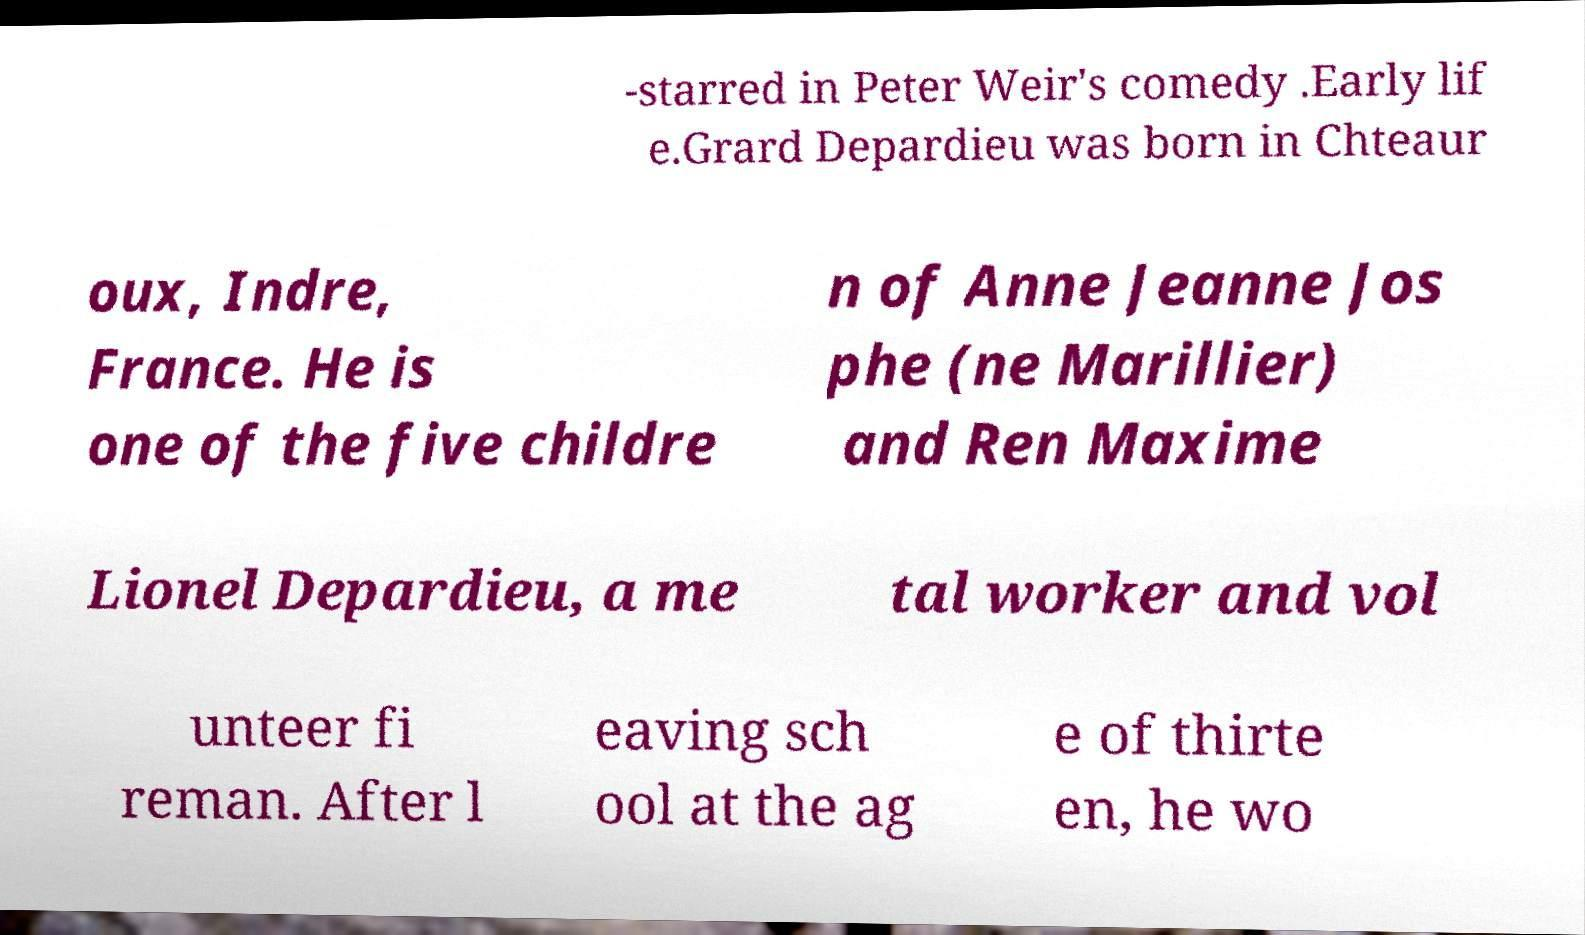Please identify and transcribe the text found in this image. -starred in Peter Weir's comedy .Early lif e.Grard Depardieu was born in Chteaur oux, Indre, France. He is one of the five childre n of Anne Jeanne Jos phe (ne Marillier) and Ren Maxime Lionel Depardieu, a me tal worker and vol unteer fi reman. After l eaving sch ool at the ag e of thirte en, he wo 